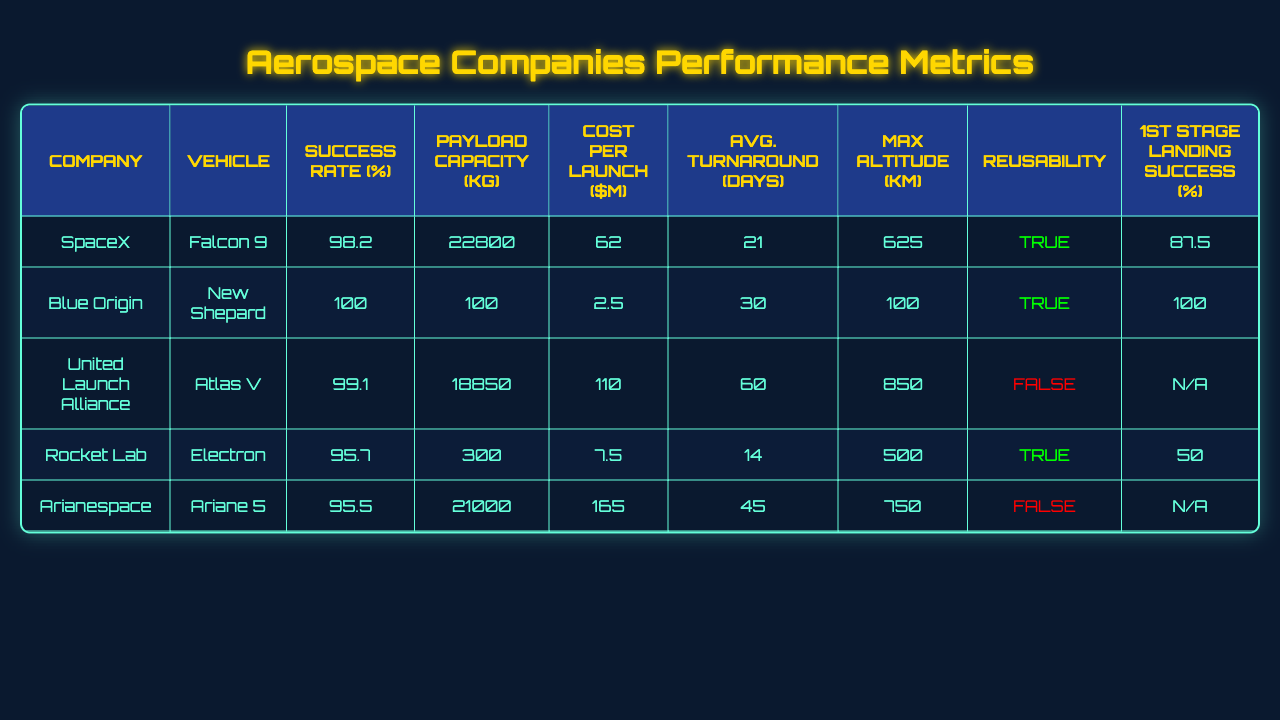What is the highest success rate among the launch vehicles? The success rates are 98.2% for Falcon 9, 100% for New Shepard, 99.1% for Atlas V, 95.7% for Electron, and 95.5% for Ariane 5. The highest success rate is 100%.
Answer: 100% Which company has the lowest cost per launch? The cost per launch for each company is as follows: SpaceX - $62M, Blue Origin - $2.5M, ULA - $110M, Rocket Lab - $7.5M, and Arianespace - $165M. The lowest cost is $2.5M from Blue Origin.
Answer: $2.5M Which launch vehicle has the highest payload capacity? The payload capacities are 22800 kg for Falcon 9, 100 kg for New Shepard, 18850 kg for Atlas V, 300 kg for Electron, and 21000 kg for Ariane 5. The highest is 22800 kg from Falcon 9.
Answer: 22800 kg Is Rocket Lab's Electron vehicle reusable? Rocket Lab's Electron is marked as true for reusability.
Answer: Yes What is the average payload capacity of the listed vehicles? The payload capacities are 22800 kg, 100 kg, 18850 kg, 300 kg, and 21000 kg. Summing these gives 22800 + 100 + 18850 + 300 + 21000 = 45850 kg. There are 5 vehicles. Dividing gives an average of 45850 / 5 = 9170 kg.
Answer: 9170 kg What is the maximum altitude capacity of the Atlas V? The table shows that the maximum altitude for Atlas V is 850 km.
Answer: 850 km Which company has the highest average turnaround days? The average turnaround days for the companies are: SpaceX - 21 days, Blue Origin - 30 days, ULA - 60 days, Rocket Lab - 14 days, and Arianespace - 45 days. The highest is 60 days from ULA.
Answer: 60 days Does any of the vehicles have a first stage landing success rate of 100%? The first stage landing success rates are 87.5% for Falcon 9, 100% for New Shepard, N/A for Atlas V, 50% for Electron, and N/A for Ariane 5. Yes, New Shepard has a success rate of 100%.
Answer: Yes Which vehicle has the longest average turnaround time, and is it reusable? The longest average turnaround is 60 days for Atlas V, which is not reusable.
Answer: Not reusable How does the cost per launch of SpaceX compare to that of Rocket Lab? SpaceX charges $62M per launch while Rocket Lab charges $7.5M. The difference is $62M - $7.5M = $54.5M, meaning SpaceX is significantly more expensive.
Answer: $54.5M difference 